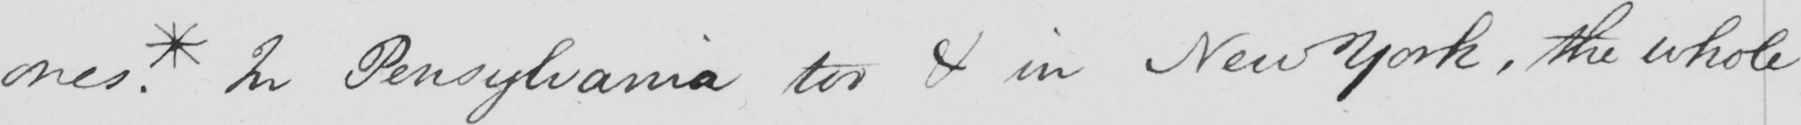What text is written in this handwritten line? ones . * In Pensylvanyia too & in New York , the whole 